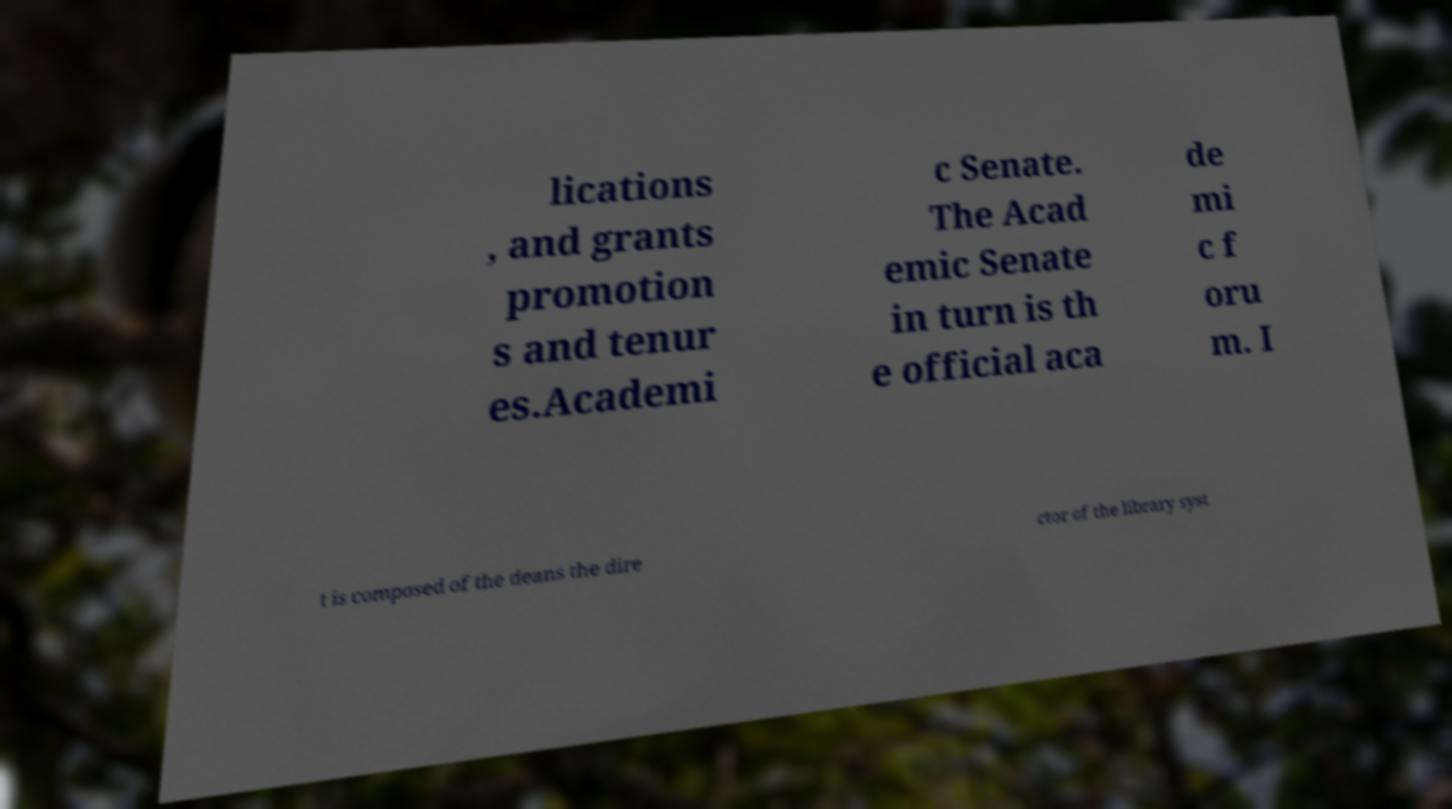Please identify and transcribe the text found in this image. lications , and grants promotion s and tenur es.Academi c Senate. The Acad emic Senate in turn is th e official aca de mi c f oru m. I t is composed of the deans the dire ctor of the library syst 